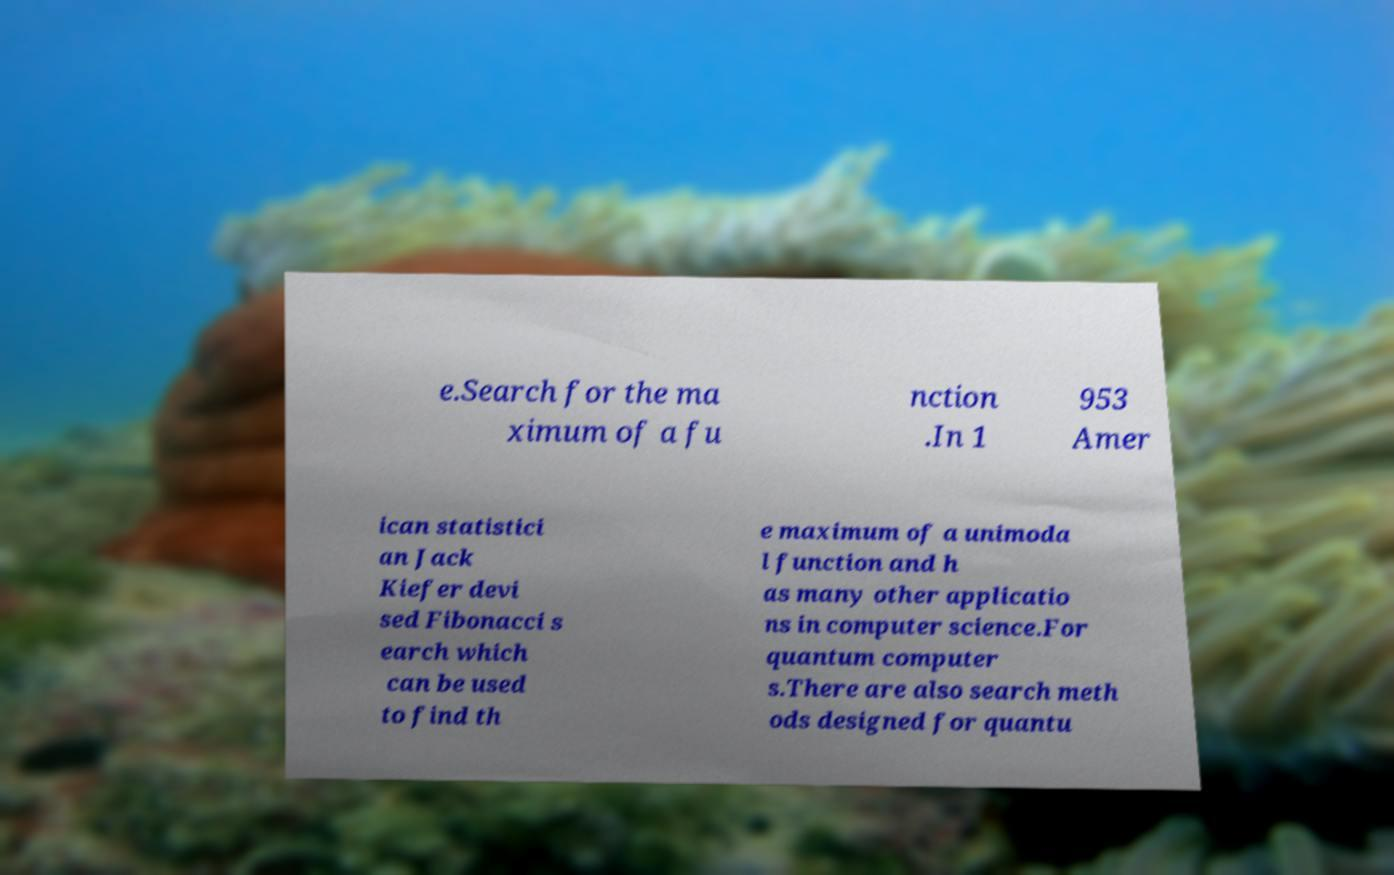There's text embedded in this image that I need extracted. Can you transcribe it verbatim? e.Search for the ma ximum of a fu nction .In 1 953 Amer ican statistici an Jack Kiefer devi sed Fibonacci s earch which can be used to find th e maximum of a unimoda l function and h as many other applicatio ns in computer science.For quantum computer s.There are also search meth ods designed for quantu 